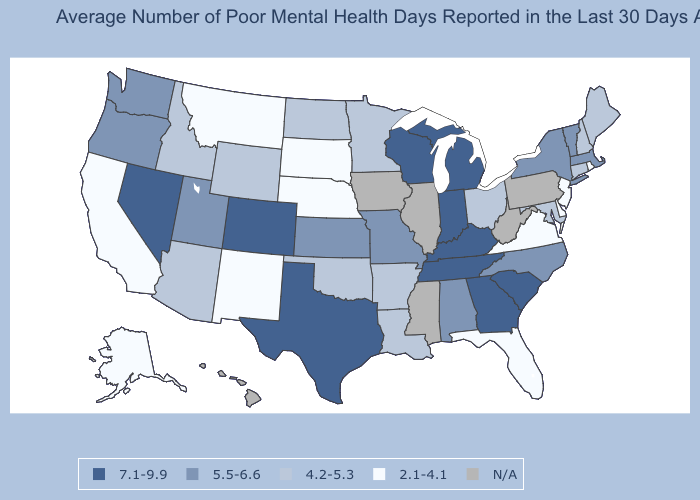Name the states that have a value in the range 5.5-6.6?
Answer briefly. Alabama, Kansas, Massachusetts, Missouri, New York, North Carolina, Oregon, Utah, Vermont, Washington. Which states have the lowest value in the USA?
Write a very short answer. Alaska, California, Delaware, Florida, Montana, Nebraska, New Jersey, New Mexico, Rhode Island, South Dakota, Virginia. What is the highest value in the MidWest ?
Be succinct. 7.1-9.9. What is the value of Hawaii?
Be succinct. N/A. Which states have the lowest value in the USA?
Keep it brief. Alaska, California, Delaware, Florida, Montana, Nebraska, New Jersey, New Mexico, Rhode Island, South Dakota, Virginia. Name the states that have a value in the range 2.1-4.1?
Short answer required. Alaska, California, Delaware, Florida, Montana, Nebraska, New Jersey, New Mexico, Rhode Island, South Dakota, Virginia. How many symbols are there in the legend?
Short answer required. 5. Among the states that border Oregon , does California have the highest value?
Be succinct. No. What is the value of Idaho?
Quick response, please. 4.2-5.3. Which states hav the highest value in the South?
Answer briefly. Georgia, Kentucky, South Carolina, Tennessee, Texas. Name the states that have a value in the range 4.2-5.3?
Be succinct. Arizona, Arkansas, Connecticut, Idaho, Louisiana, Maine, Maryland, Minnesota, New Hampshire, North Dakota, Ohio, Oklahoma, Wyoming. Name the states that have a value in the range N/A?
Concise answer only. Hawaii, Illinois, Iowa, Mississippi, Pennsylvania, West Virginia. Which states hav the highest value in the South?
Give a very brief answer. Georgia, Kentucky, South Carolina, Tennessee, Texas. Name the states that have a value in the range 4.2-5.3?
Concise answer only. Arizona, Arkansas, Connecticut, Idaho, Louisiana, Maine, Maryland, Minnesota, New Hampshire, North Dakota, Ohio, Oklahoma, Wyoming. 